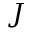<formula> <loc_0><loc_0><loc_500><loc_500>J</formula> 